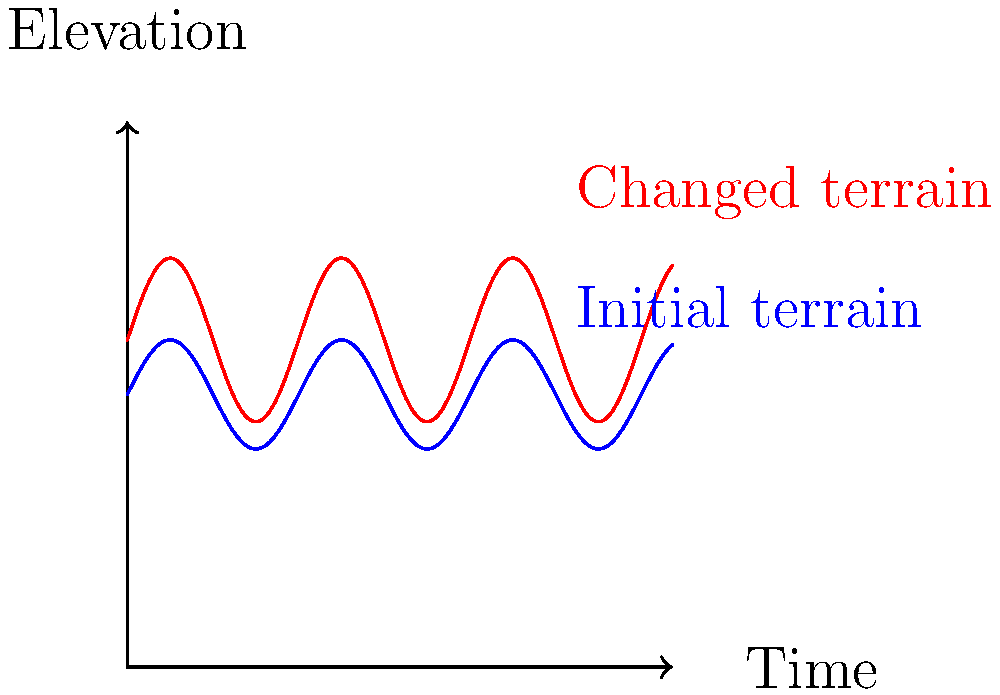As a veteran with experience in terrain analysis, how would you interpret the changes shown in this satellite imagery-derived elevation graph over time? What factors might contribute to such changes, and how could this information be crucial in military operations? 1. Interpret the graph:
   - The blue line represents the initial terrain elevation.
   - The red line shows the changed terrain elevation over time.
   - Both lines follow a sinusoidal pattern, indicating a repetitive landscape feature.

2. Analyze the changes:
   - The overall elevation has increased (red line is higher than blue).
   - The amplitude of the terrain variations has increased (red line has larger peaks and troughs).

3. Potential contributing factors:
   - Natural causes: Tectonic activity, erosion, or deposition.
   - Human activities: Construction, mining, or terraforming.
   - Seasonal changes: Snow accumulation or vegetation growth.

4. Military significance:
   - Changes in elevation can affect line-of-sight for surveillance and targeting.
   - Altered terrain may impact vehicle mobility and troop movements.
   - New features could provide cover or expose vulnerabilities.

5. Application of satellite imagery analysis:
   - Allows for remote monitoring of terrain changes over time.
   - Helps in identifying potential threats or strategic advantages.
   - Enables better planning and adaptation of military strategies.

6. Veteran's perspective:
   - Experience in interpreting such data is crucial for mission planning.
   - Understanding terrain changes can be life-saving in combat situations.
   - This type of analysis would have been valuable in past operations.
Answer: Elevation increase and amplified terrain variations, possibly due to natural or human factors, significantly impacting military strategies and operations. 